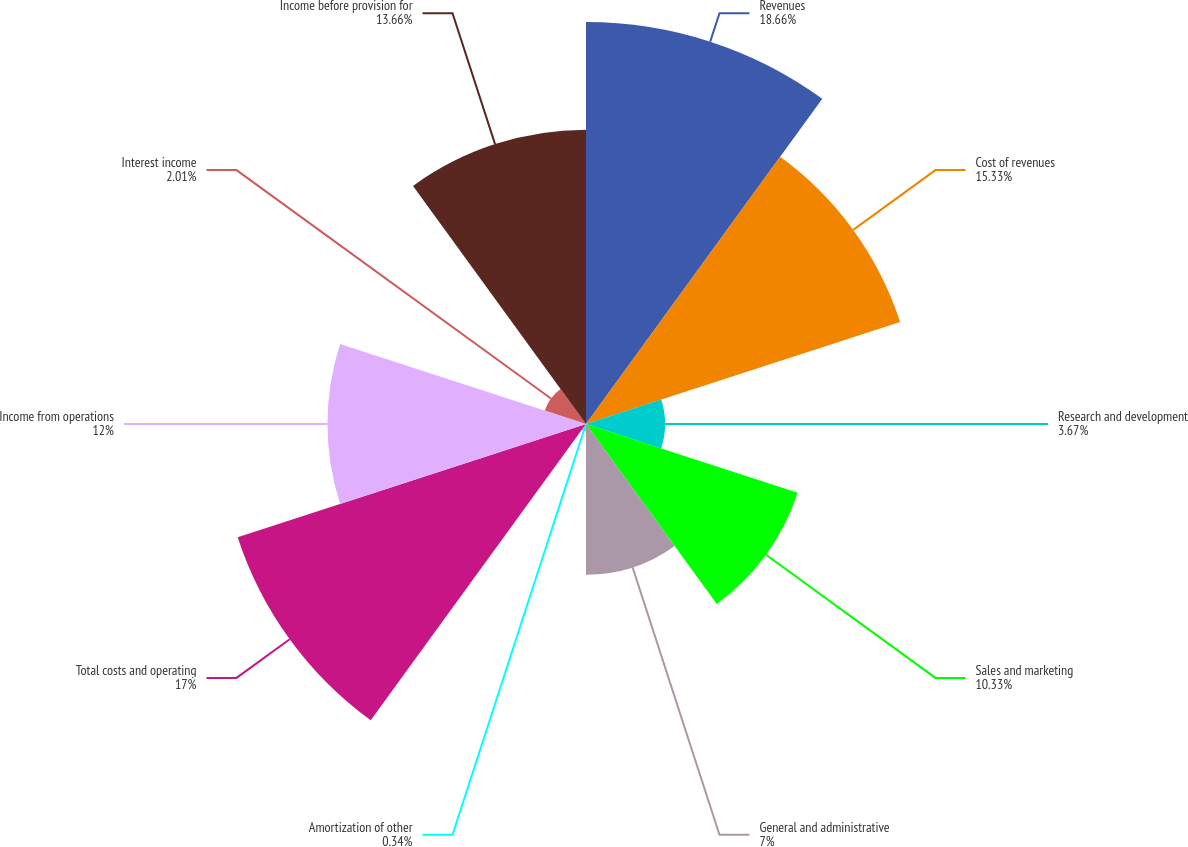Convert chart to OTSL. <chart><loc_0><loc_0><loc_500><loc_500><pie_chart><fcel>Revenues<fcel>Cost of revenues<fcel>Research and development<fcel>Sales and marketing<fcel>General and administrative<fcel>Amortization of other<fcel>Total costs and operating<fcel>Income from operations<fcel>Interest income<fcel>Income before provision for<nl><fcel>18.66%<fcel>15.33%<fcel>3.67%<fcel>10.33%<fcel>7.0%<fcel>0.34%<fcel>17.0%<fcel>12.0%<fcel>2.01%<fcel>13.66%<nl></chart> 